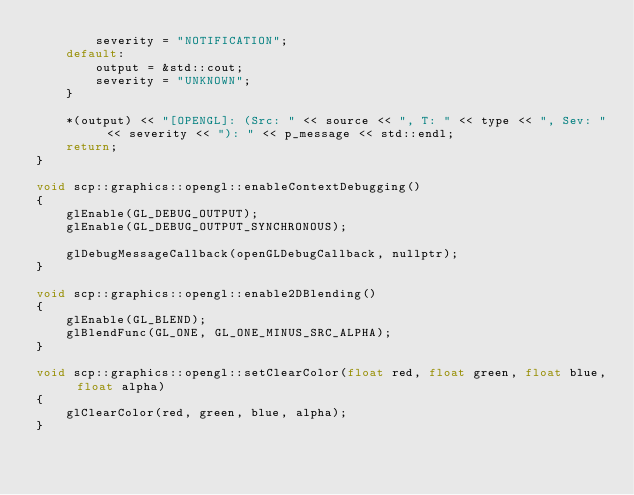<code> <loc_0><loc_0><loc_500><loc_500><_C++_>        severity = "NOTIFICATION";
    default:
        output = &std::cout;
        severity = "UNKNOWN";
    }
    
    *(output) << "[OPENGL]: (Src: " << source << ", T: " << type << ", Sev: " << severity << "): " << p_message << std::endl;
    return;
}

void scp::graphics::opengl::enableContextDebugging()
{
    glEnable(GL_DEBUG_OUTPUT);
    glEnable(GL_DEBUG_OUTPUT_SYNCHRONOUS);
    
    glDebugMessageCallback(openGLDebugCallback, nullptr);
}

void scp::graphics::opengl::enable2DBlending()
{
    glEnable(GL_BLEND);
    glBlendFunc(GL_ONE, GL_ONE_MINUS_SRC_ALPHA);
}

void scp::graphics::opengl::setClearColor(float red, float green, float blue, float alpha)
{
    glClearColor(red, green, blue, alpha);
}
</code> 